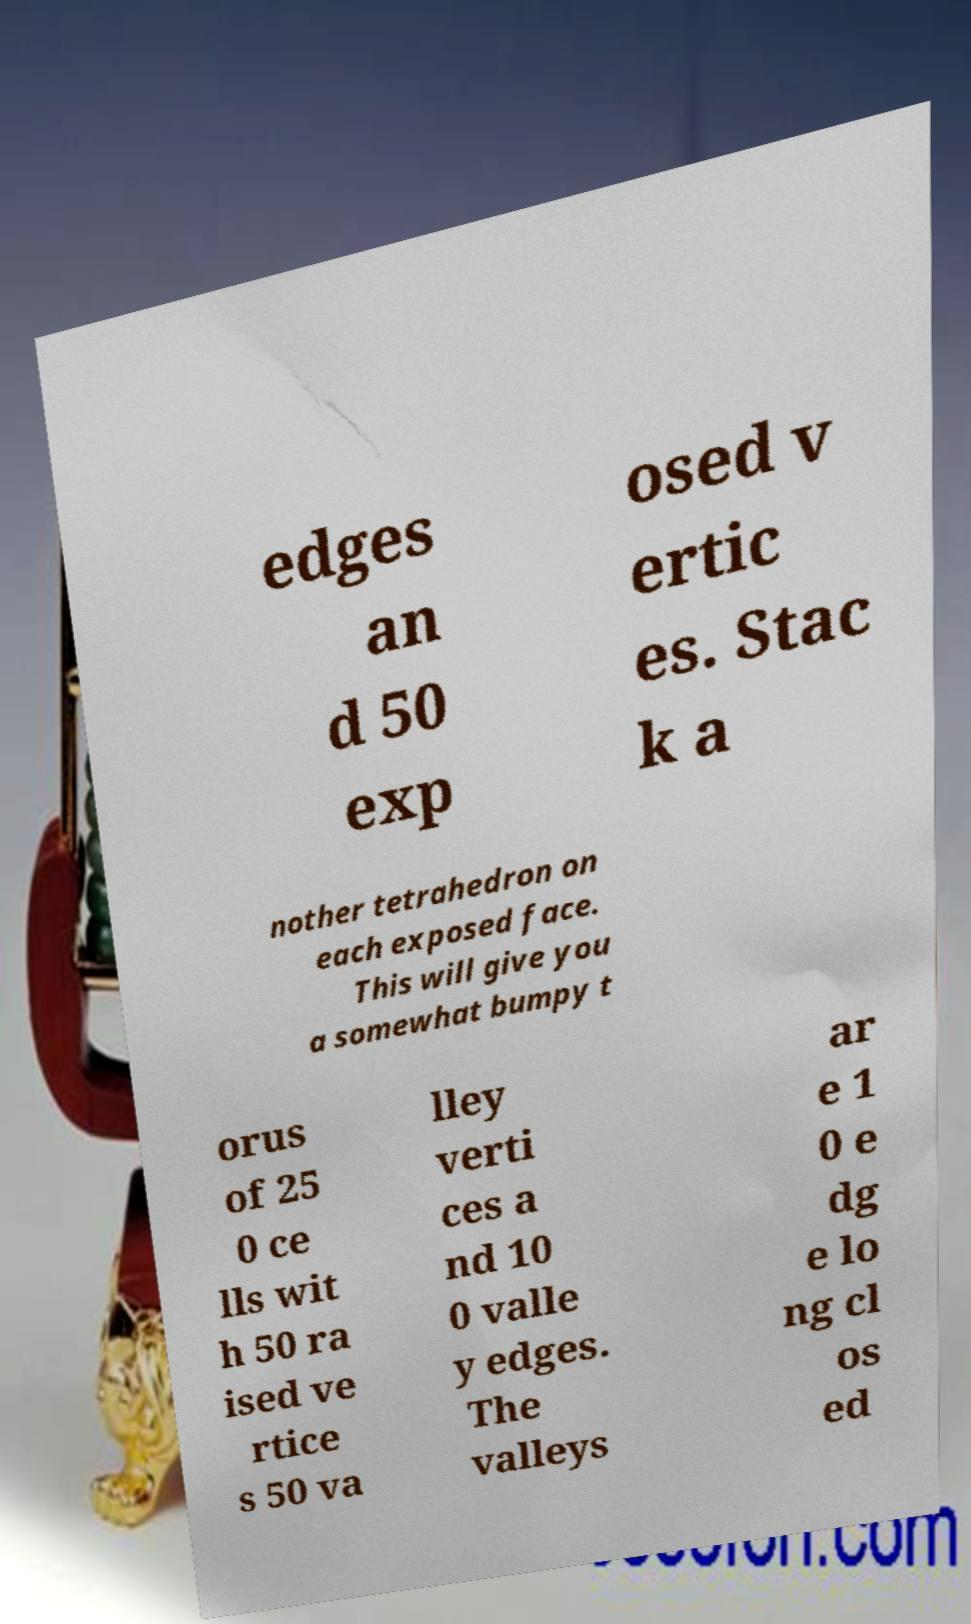Could you assist in decoding the text presented in this image and type it out clearly? edges an d 50 exp osed v ertic es. Stac k a nother tetrahedron on each exposed face. This will give you a somewhat bumpy t orus of 25 0 ce lls wit h 50 ra ised ve rtice s 50 va lley verti ces a nd 10 0 valle y edges. The valleys ar e 1 0 e dg e lo ng cl os ed 